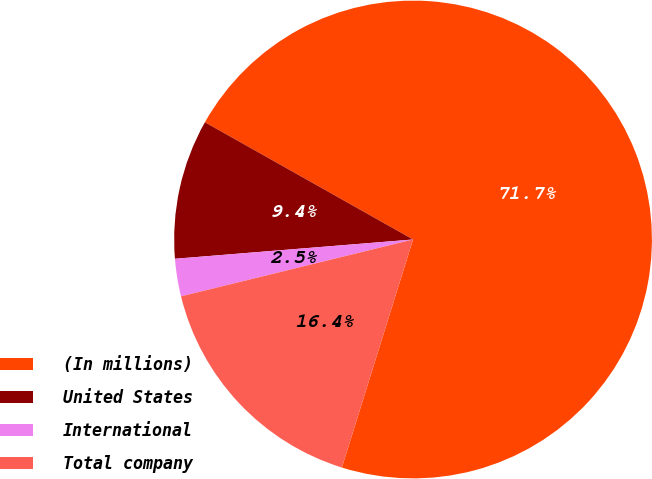<chart> <loc_0><loc_0><loc_500><loc_500><pie_chart><fcel>(In millions)<fcel>United States<fcel>International<fcel>Total company<nl><fcel>71.65%<fcel>9.45%<fcel>2.54%<fcel>16.36%<nl></chart> 